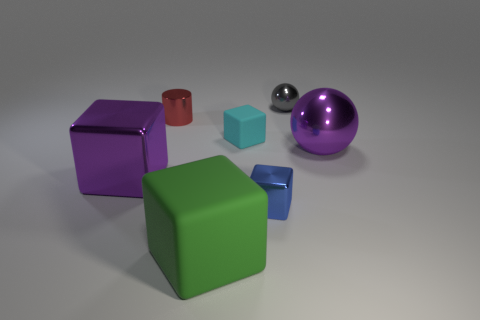How many other cyan rubber objects are the same shape as the small matte object?
Provide a short and direct response. 0. How many red things are tiny rubber objects or rubber cubes?
Ensure brevity in your answer.  0. There is a gray metallic thing on the left side of the big purple metallic object to the right of the tiny gray metallic thing; how big is it?
Provide a succinct answer. Small. There is another purple thing that is the same shape as the large matte thing; what is its material?
Your answer should be compact. Metal. What number of other purple shiny cylinders are the same size as the shiny cylinder?
Keep it short and to the point. 0. Is the gray metal sphere the same size as the green cube?
Keep it short and to the point. No. What size is the shiny object that is both right of the large shiny cube and to the left of the small blue metal object?
Your answer should be very brief. Small. Is the number of small blue metal cubes that are right of the tiny blue shiny cube greater than the number of big metal spheres behind the cyan rubber block?
Offer a very short reply. No. The big object that is the same shape as the small gray shiny thing is what color?
Provide a short and direct response. Purple. Is the color of the large metal object that is on the right side of the small gray shiny object the same as the small metal ball?
Your response must be concise. No. 